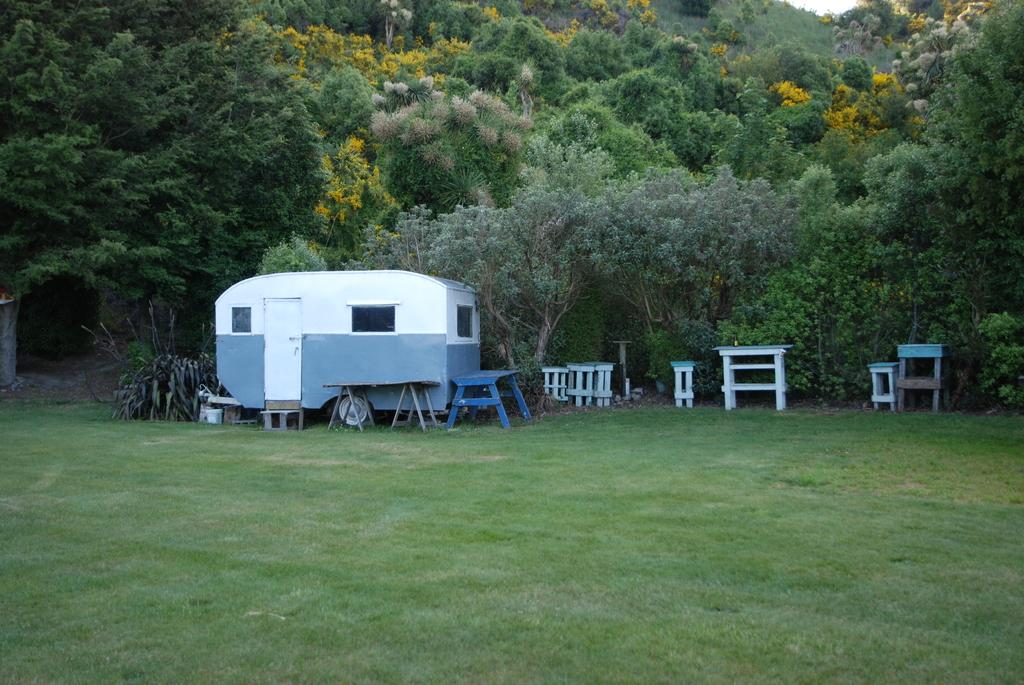What type of vehicle is in the image? There is a carry van in the image. What type of furniture is in the image? There are tables and stools in the image. What type of vegetation is in the image? There are plants, trees, and grass in the image. What part of the natural environment is visible in the image? The sky is visible in the image. What type of powder is being used to treat patients in the image? There is no hospital or patients present in the image, and therefore no powder being used for treatment. 